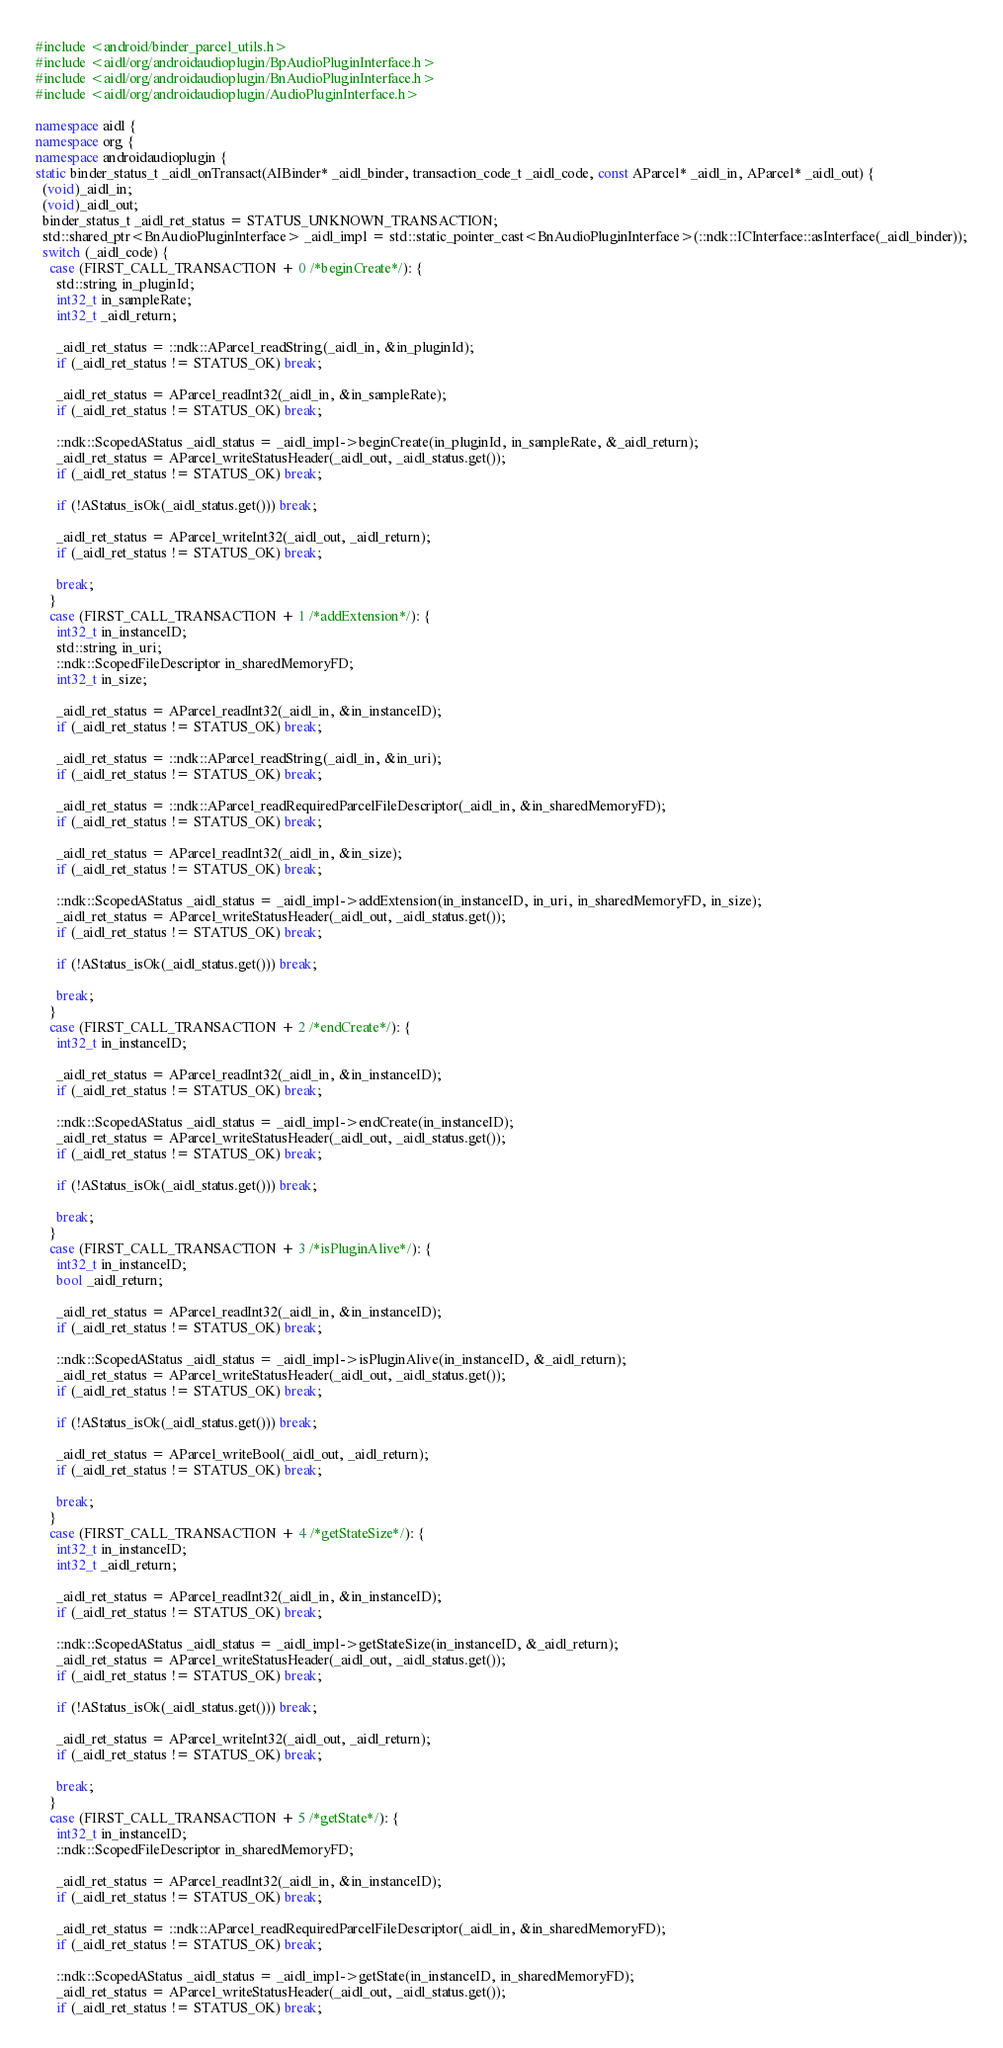<code> <loc_0><loc_0><loc_500><loc_500><_C++_>#include <android/binder_parcel_utils.h>
#include <aidl/org/androidaudioplugin/BpAudioPluginInterface.h>
#include <aidl/org/androidaudioplugin/BnAudioPluginInterface.h>
#include <aidl/org/androidaudioplugin/AudioPluginInterface.h>

namespace aidl {
namespace org {
namespace androidaudioplugin {
static binder_status_t _aidl_onTransact(AIBinder* _aidl_binder, transaction_code_t _aidl_code, const AParcel* _aidl_in, AParcel* _aidl_out) {
  (void)_aidl_in;
  (void)_aidl_out;
  binder_status_t _aidl_ret_status = STATUS_UNKNOWN_TRANSACTION;
  std::shared_ptr<BnAudioPluginInterface> _aidl_impl = std::static_pointer_cast<BnAudioPluginInterface>(::ndk::ICInterface::asInterface(_aidl_binder));
  switch (_aidl_code) {
    case (FIRST_CALL_TRANSACTION + 0 /*beginCreate*/): {
      std::string in_pluginId;
      int32_t in_sampleRate;
      int32_t _aidl_return;

      _aidl_ret_status = ::ndk::AParcel_readString(_aidl_in, &in_pluginId);
      if (_aidl_ret_status != STATUS_OK) break;

      _aidl_ret_status = AParcel_readInt32(_aidl_in, &in_sampleRate);
      if (_aidl_ret_status != STATUS_OK) break;

      ::ndk::ScopedAStatus _aidl_status = _aidl_impl->beginCreate(in_pluginId, in_sampleRate, &_aidl_return);
      _aidl_ret_status = AParcel_writeStatusHeader(_aidl_out, _aidl_status.get());
      if (_aidl_ret_status != STATUS_OK) break;

      if (!AStatus_isOk(_aidl_status.get())) break;

      _aidl_ret_status = AParcel_writeInt32(_aidl_out, _aidl_return);
      if (_aidl_ret_status != STATUS_OK) break;

      break;
    }
    case (FIRST_CALL_TRANSACTION + 1 /*addExtension*/): {
      int32_t in_instanceID;
      std::string in_uri;
      ::ndk::ScopedFileDescriptor in_sharedMemoryFD;
      int32_t in_size;

      _aidl_ret_status = AParcel_readInt32(_aidl_in, &in_instanceID);
      if (_aidl_ret_status != STATUS_OK) break;

      _aidl_ret_status = ::ndk::AParcel_readString(_aidl_in, &in_uri);
      if (_aidl_ret_status != STATUS_OK) break;

      _aidl_ret_status = ::ndk::AParcel_readRequiredParcelFileDescriptor(_aidl_in, &in_sharedMemoryFD);
      if (_aidl_ret_status != STATUS_OK) break;

      _aidl_ret_status = AParcel_readInt32(_aidl_in, &in_size);
      if (_aidl_ret_status != STATUS_OK) break;

      ::ndk::ScopedAStatus _aidl_status = _aidl_impl->addExtension(in_instanceID, in_uri, in_sharedMemoryFD, in_size);
      _aidl_ret_status = AParcel_writeStatusHeader(_aidl_out, _aidl_status.get());
      if (_aidl_ret_status != STATUS_OK) break;

      if (!AStatus_isOk(_aidl_status.get())) break;

      break;
    }
    case (FIRST_CALL_TRANSACTION + 2 /*endCreate*/): {
      int32_t in_instanceID;

      _aidl_ret_status = AParcel_readInt32(_aidl_in, &in_instanceID);
      if (_aidl_ret_status != STATUS_OK) break;

      ::ndk::ScopedAStatus _aidl_status = _aidl_impl->endCreate(in_instanceID);
      _aidl_ret_status = AParcel_writeStatusHeader(_aidl_out, _aidl_status.get());
      if (_aidl_ret_status != STATUS_OK) break;

      if (!AStatus_isOk(_aidl_status.get())) break;

      break;
    }
    case (FIRST_CALL_TRANSACTION + 3 /*isPluginAlive*/): {
      int32_t in_instanceID;
      bool _aidl_return;

      _aidl_ret_status = AParcel_readInt32(_aidl_in, &in_instanceID);
      if (_aidl_ret_status != STATUS_OK) break;

      ::ndk::ScopedAStatus _aidl_status = _aidl_impl->isPluginAlive(in_instanceID, &_aidl_return);
      _aidl_ret_status = AParcel_writeStatusHeader(_aidl_out, _aidl_status.get());
      if (_aidl_ret_status != STATUS_OK) break;

      if (!AStatus_isOk(_aidl_status.get())) break;

      _aidl_ret_status = AParcel_writeBool(_aidl_out, _aidl_return);
      if (_aidl_ret_status != STATUS_OK) break;

      break;
    }
    case (FIRST_CALL_TRANSACTION + 4 /*getStateSize*/): {
      int32_t in_instanceID;
      int32_t _aidl_return;

      _aidl_ret_status = AParcel_readInt32(_aidl_in, &in_instanceID);
      if (_aidl_ret_status != STATUS_OK) break;

      ::ndk::ScopedAStatus _aidl_status = _aidl_impl->getStateSize(in_instanceID, &_aidl_return);
      _aidl_ret_status = AParcel_writeStatusHeader(_aidl_out, _aidl_status.get());
      if (_aidl_ret_status != STATUS_OK) break;

      if (!AStatus_isOk(_aidl_status.get())) break;

      _aidl_ret_status = AParcel_writeInt32(_aidl_out, _aidl_return);
      if (_aidl_ret_status != STATUS_OK) break;

      break;
    }
    case (FIRST_CALL_TRANSACTION + 5 /*getState*/): {
      int32_t in_instanceID;
      ::ndk::ScopedFileDescriptor in_sharedMemoryFD;

      _aidl_ret_status = AParcel_readInt32(_aidl_in, &in_instanceID);
      if (_aidl_ret_status != STATUS_OK) break;

      _aidl_ret_status = ::ndk::AParcel_readRequiredParcelFileDescriptor(_aidl_in, &in_sharedMemoryFD);
      if (_aidl_ret_status != STATUS_OK) break;

      ::ndk::ScopedAStatus _aidl_status = _aidl_impl->getState(in_instanceID, in_sharedMemoryFD);
      _aidl_ret_status = AParcel_writeStatusHeader(_aidl_out, _aidl_status.get());
      if (_aidl_ret_status != STATUS_OK) break;
</code> 